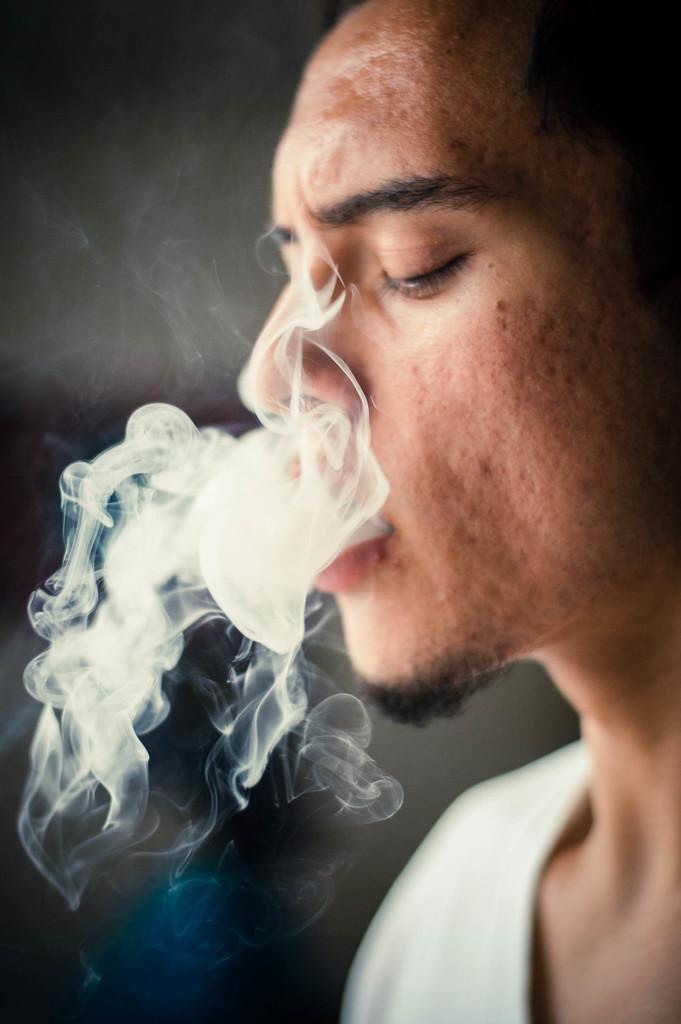Can you describe this image briefly? In this image, we can see a person. Background it is blur view. Here person is exhaling the smoke. 